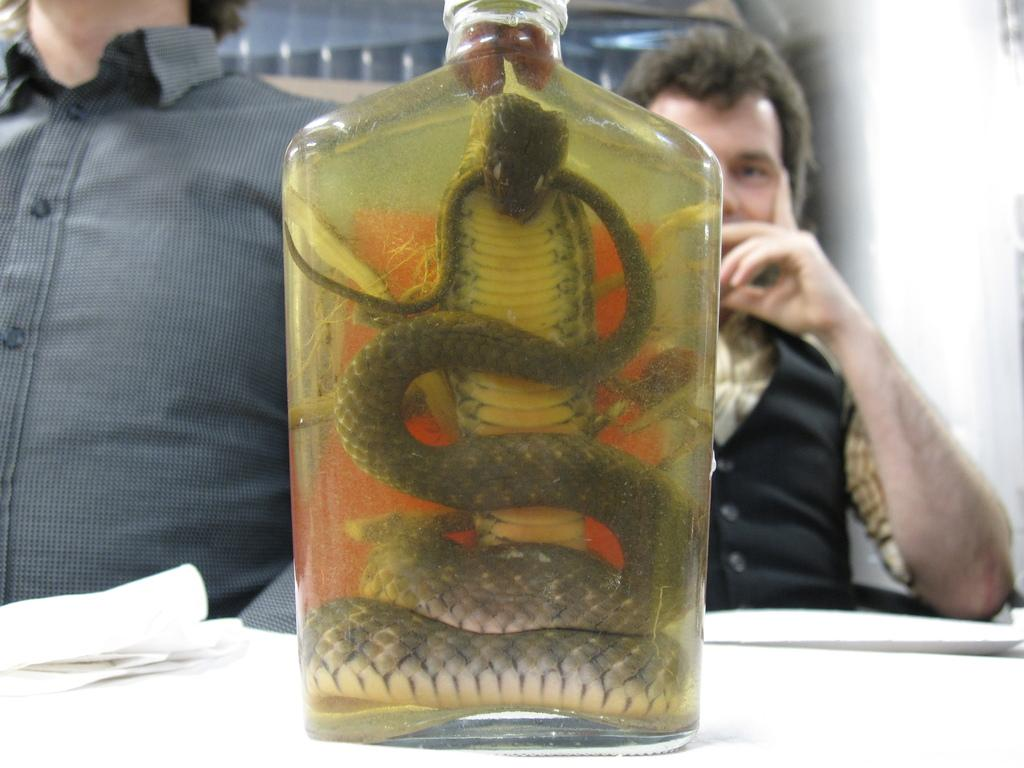How many people are in the image? There are two persons in the image. What is the main object in the image? There is a table in the image. What items can be seen on the table? Tissue papers and a bottle are present on the table. What is inside the bottle? A snake is visible inside the bottle. What type of hair is visible on the table in the image? There is no hair visible on the table in the image. Is there a toothbrush present in the image? No, there is no toothbrush present in the image. 